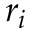<formula> <loc_0><loc_0><loc_500><loc_500>r _ { i }</formula> 